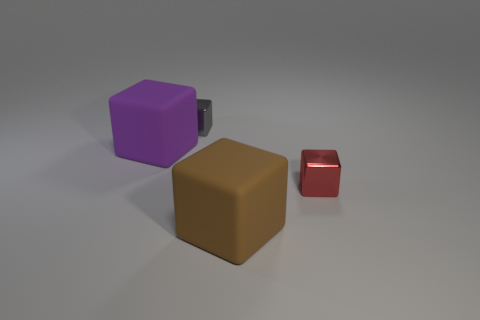Add 1 small gray blocks. How many objects exist? 5 Subtract all cyan cubes. Subtract all purple spheres. How many cubes are left? 4 Add 4 big brown blocks. How many big brown blocks are left? 5 Add 4 small purple rubber cubes. How many small purple rubber cubes exist? 4 Subtract 1 red cubes. How many objects are left? 3 Subtract all large purple metal balls. Subtract all tiny red metal objects. How many objects are left? 3 